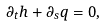<formula> <loc_0><loc_0><loc_500><loc_500>\partial _ { t } h + \partial _ { s } q = 0 ,</formula> 